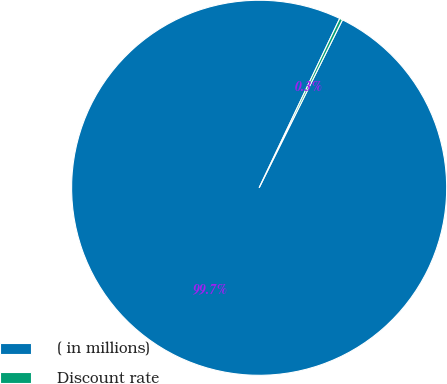<chart> <loc_0><loc_0><loc_500><loc_500><pie_chart><fcel>( in millions)<fcel>Discount rate<nl><fcel>99.74%<fcel>0.26%<nl></chart> 